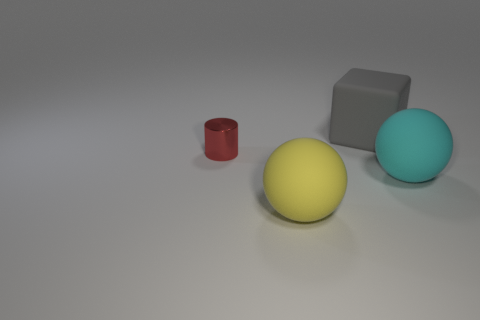Is the number of matte balls less than the number of cubes? No, the number of matte balls is not less than the number of cubes. In the image, there is one matte yellow ball and one cube, so they are equal in number. 